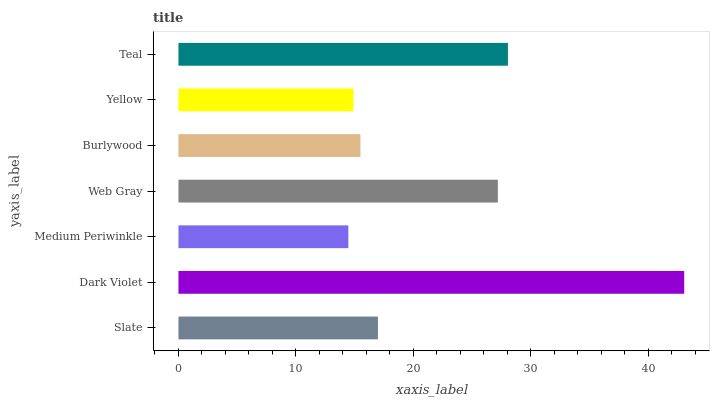Is Medium Periwinkle the minimum?
Answer yes or no. Yes. Is Dark Violet the maximum?
Answer yes or no. Yes. Is Dark Violet the minimum?
Answer yes or no. No. Is Medium Periwinkle the maximum?
Answer yes or no. No. Is Dark Violet greater than Medium Periwinkle?
Answer yes or no. Yes. Is Medium Periwinkle less than Dark Violet?
Answer yes or no. Yes. Is Medium Periwinkle greater than Dark Violet?
Answer yes or no. No. Is Dark Violet less than Medium Periwinkle?
Answer yes or no. No. Is Slate the high median?
Answer yes or no. Yes. Is Slate the low median?
Answer yes or no. Yes. Is Yellow the high median?
Answer yes or no. No. Is Dark Violet the low median?
Answer yes or no. No. 